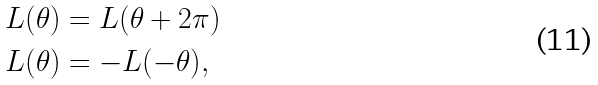<formula> <loc_0><loc_0><loc_500><loc_500>& L ( \theta ) = L ( \theta + 2 \pi ) \\ & L ( \theta ) = - L ( - \theta ) ,</formula> 